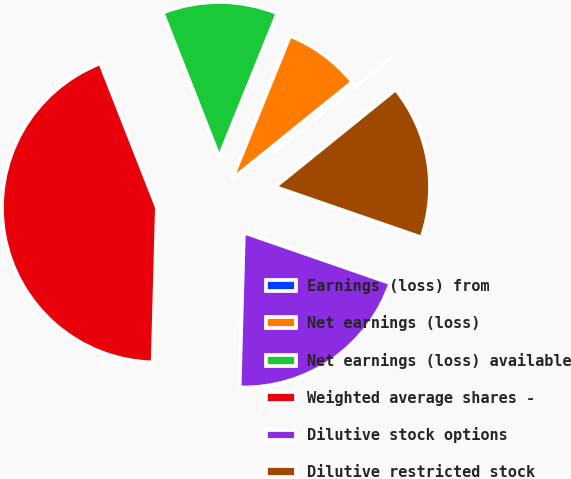Convert chart to OTSL. <chart><loc_0><loc_0><loc_500><loc_500><pie_chart><fcel>Earnings (loss) from<fcel>Net earnings (loss)<fcel>Net earnings (loss) available<fcel>Weighted average shares -<fcel>Dilutive stock options<fcel>Dilutive restricted stock<nl><fcel>0.0%<fcel>8.06%<fcel>12.08%<fcel>43.61%<fcel>20.14%<fcel>16.11%<nl></chart> 